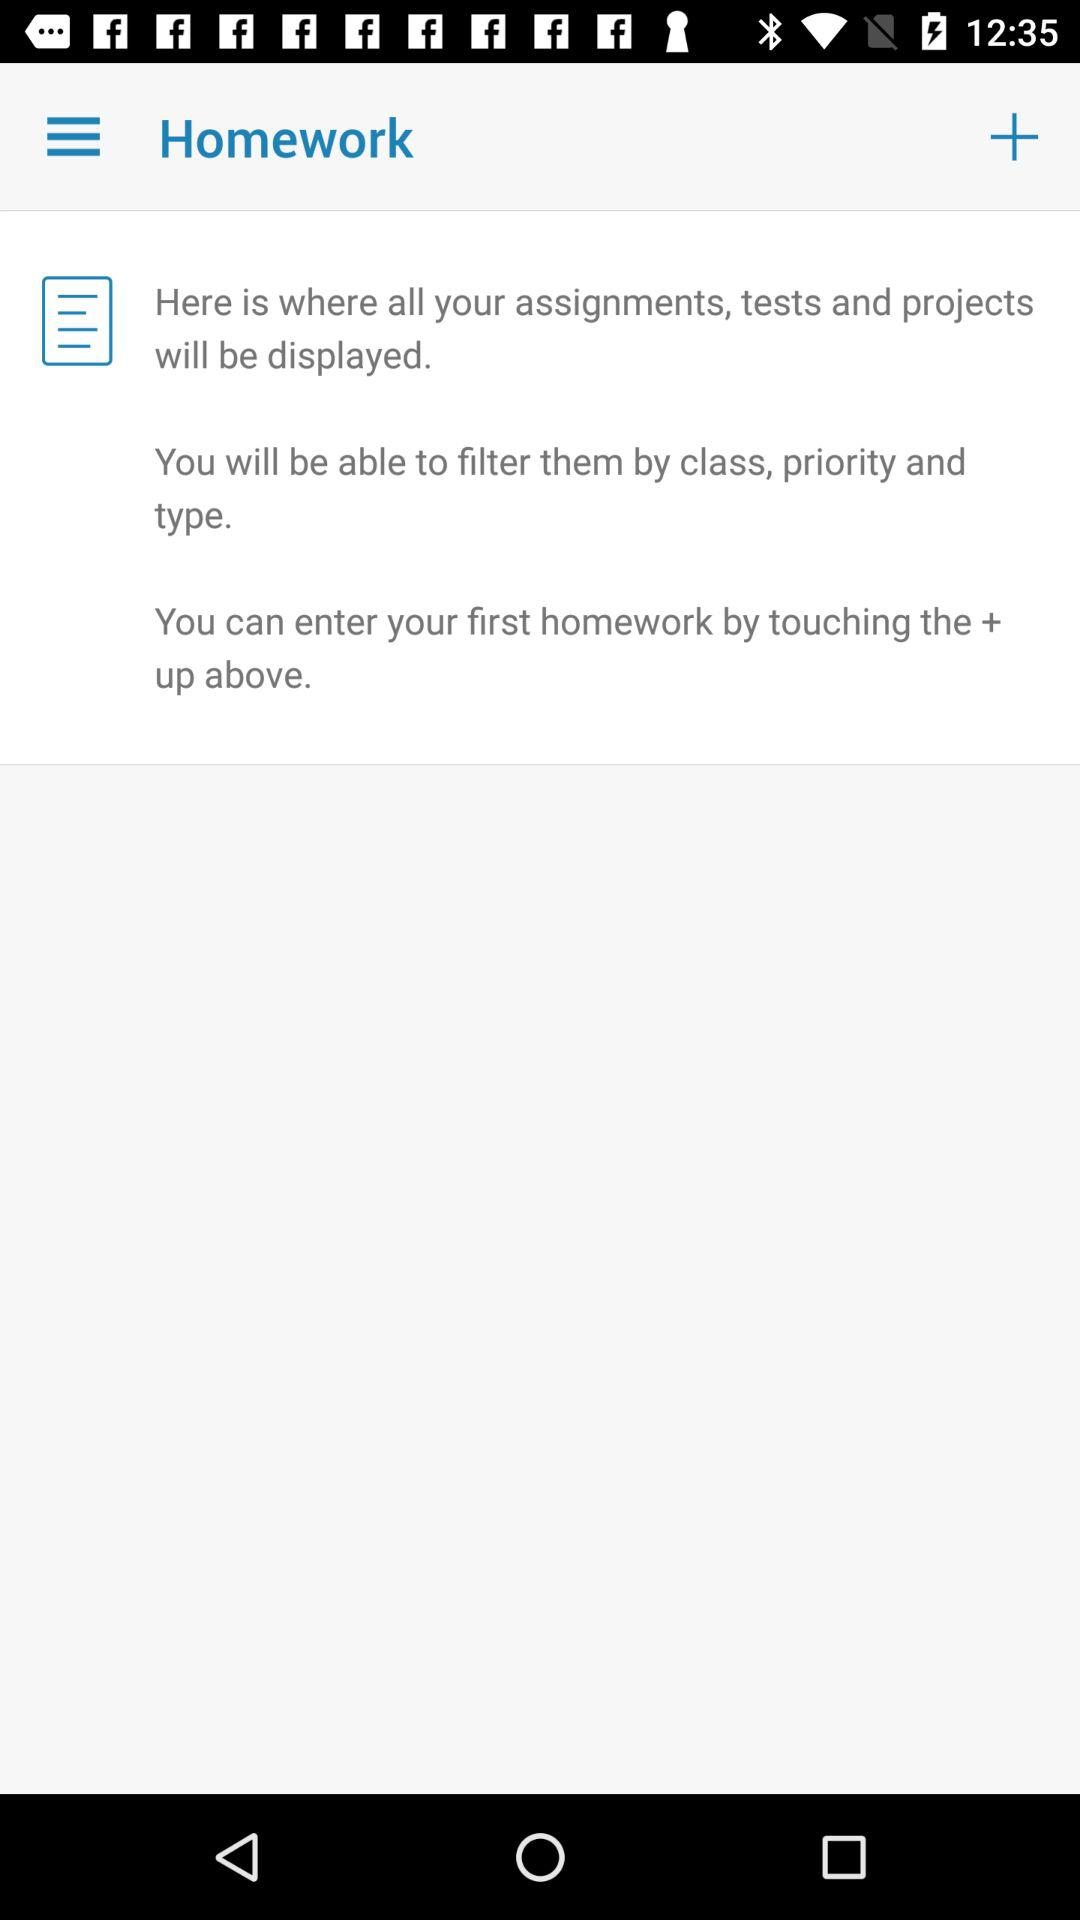How can we enter our first homework? You can enter your first homework by touching the + up above. 